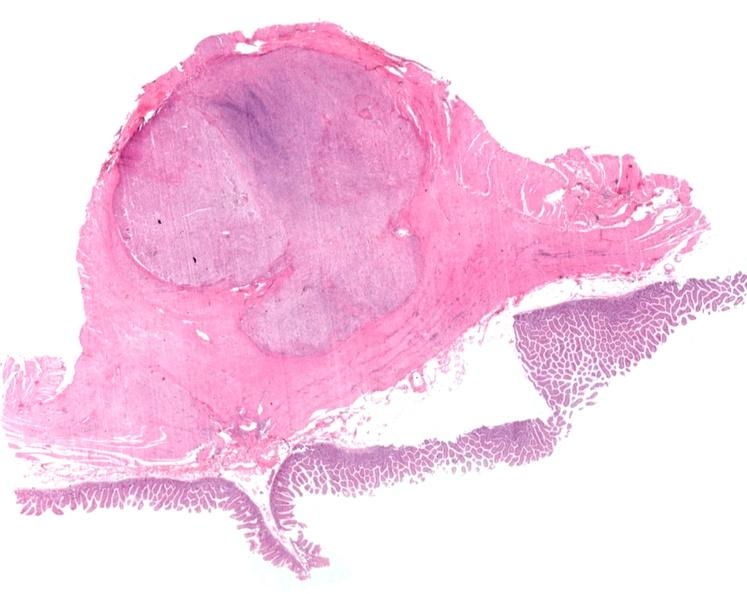s gastrointestinal present?
Answer the question using a single word or phrase. Yes 